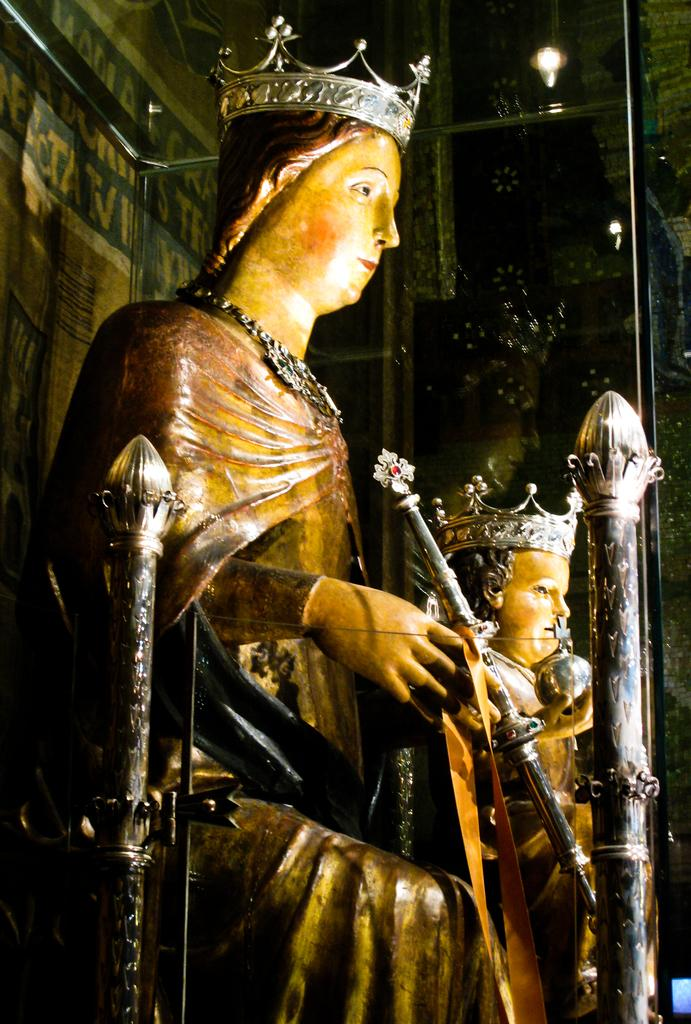What type of figures are depicted in the image? There are statues of people with crowns in the image. What objects can be seen in the image besides the statues? There are poles visible in the image. What can be seen in the background of the image? There is glass in the background of the image. Are there any other objects visible in the background? Yes, there are additional poles in the background of the image. What type of dime can be seen in the image? There is no dime present in the image. Can you see any steam coming from the statues in the image? There is no steam visible in the image. 